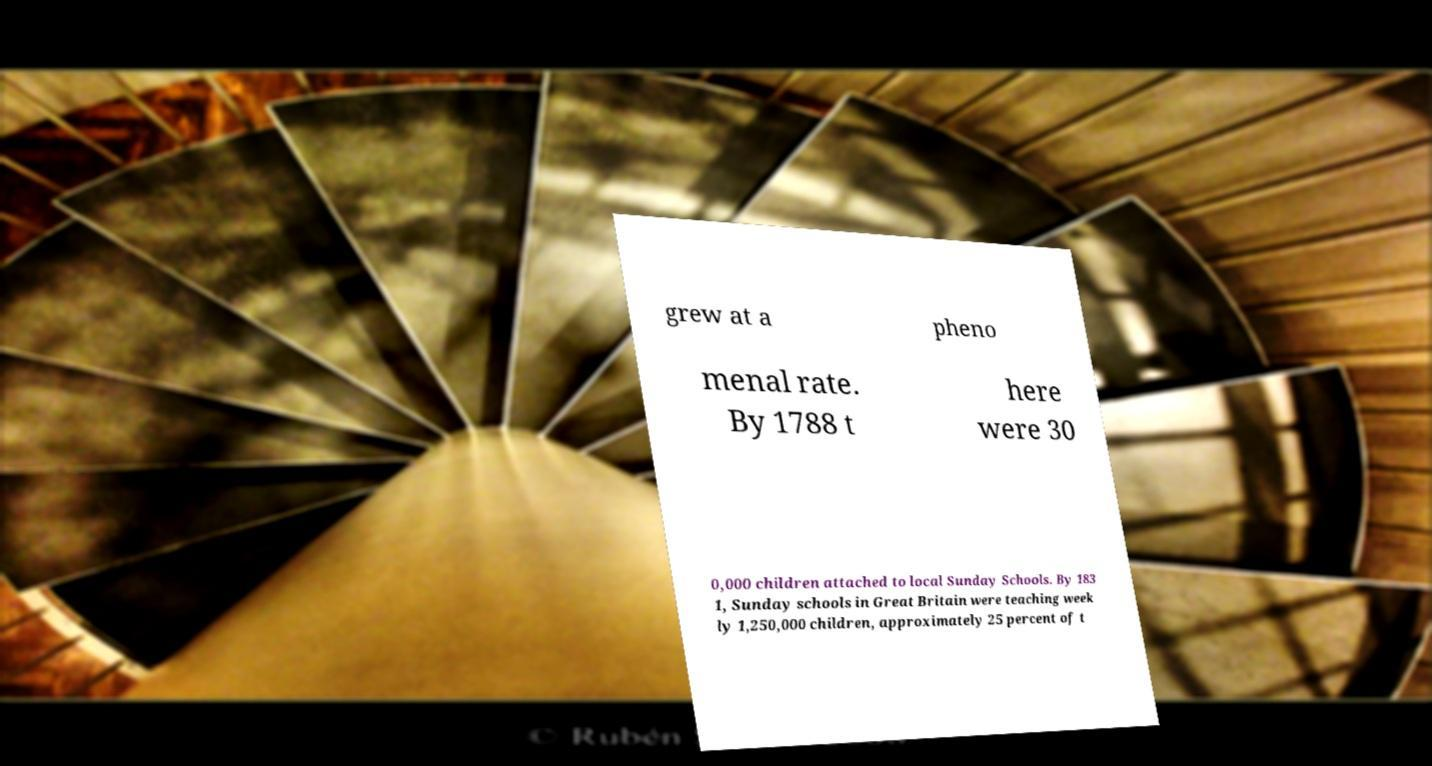What messages or text are displayed in this image? I need them in a readable, typed format. grew at a pheno menal rate. By 1788 t here were 30 0,000 children attached to local Sunday Schools. By 183 1, Sunday schools in Great Britain were teaching week ly 1,250,000 children, approximately 25 percent of t 